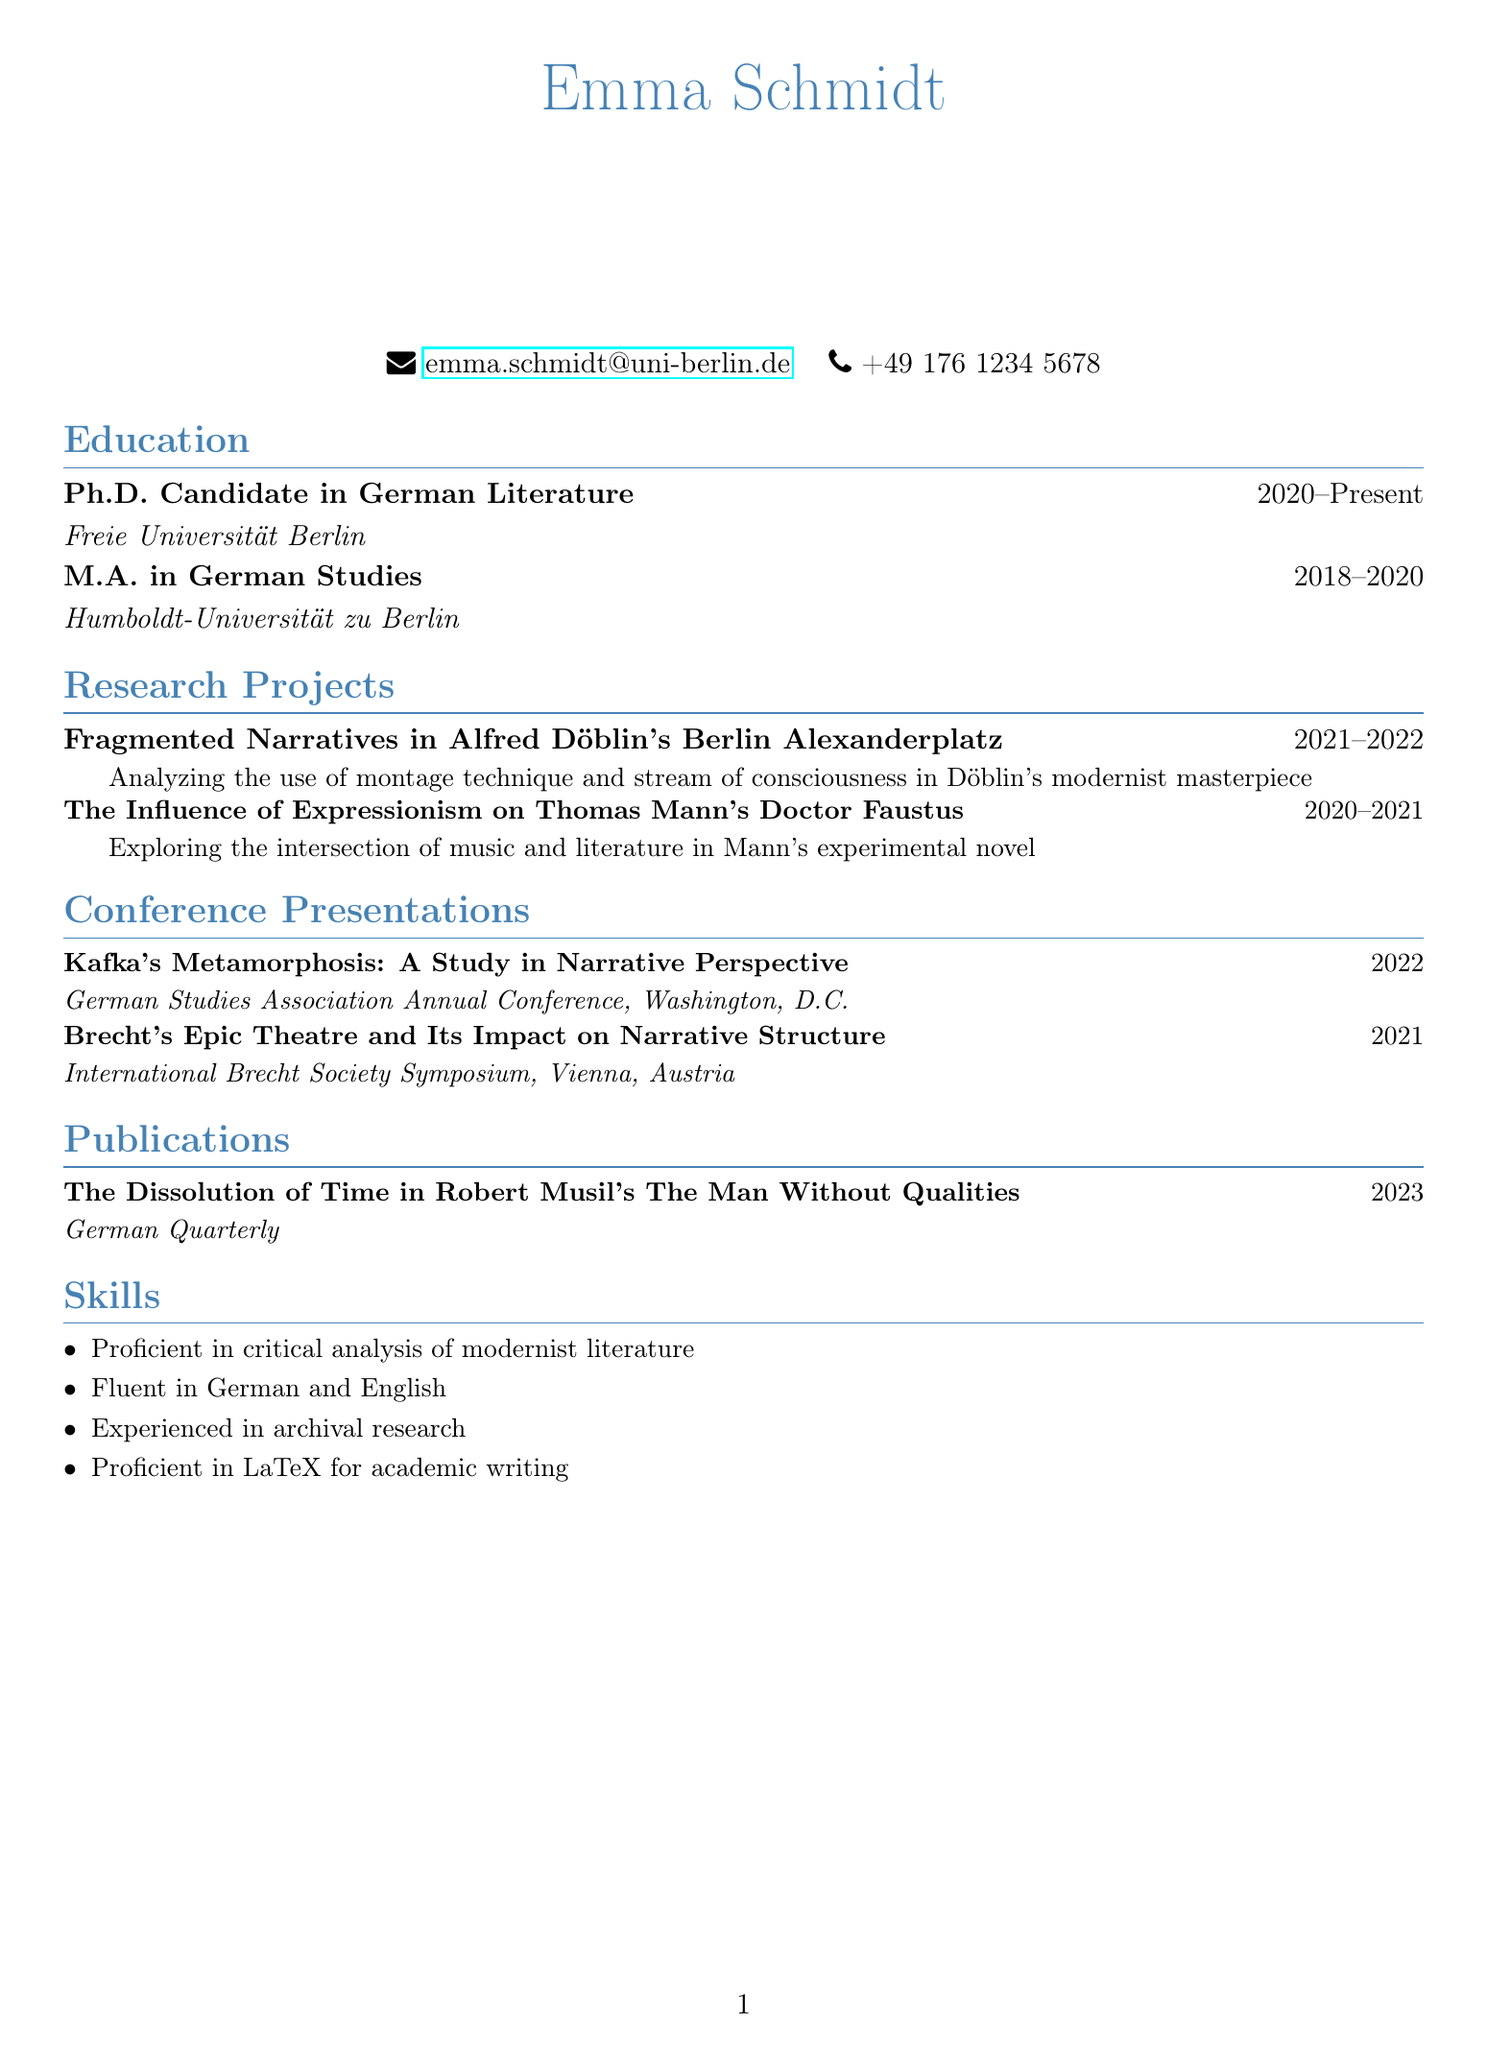What is Emma Schmidt's email address? The email address is listed under personal information in the document.
Answer: emma.schmidt@uni-berlin.de In which year did Emma start her Ph.D. program? The starting year of the Ph.D. program is provided in the education section of the document.
Answer: 2020 What is the title of Emma's recent publication? The title of the publication is found in the publications section of the document.
Answer: The Dissolution of Time in Robert Musil's The Man Without Qualities Which conference did Emma present at in 2022? The conference title is listed under the conference presentations section.
Answer: German Studies Association Annual Conference How many research projects has Emma listed? The number of research projects is determined by counting the entries in the research projects section.
Answer: 2 What narrative technique does Emma analyze in her project on Döblin? The narrative technique is specified in the description of the research project.
Answer: Montage technique and stream of consciousness What language is Emma fluent in? The languages Emma is fluent in are stated in the skills section of the document.
Answer: German and English Where was the International Brecht Society Symposium held? The location of the symposium is detailed in the conference presentations section.
Answer: Vienna, Austria 